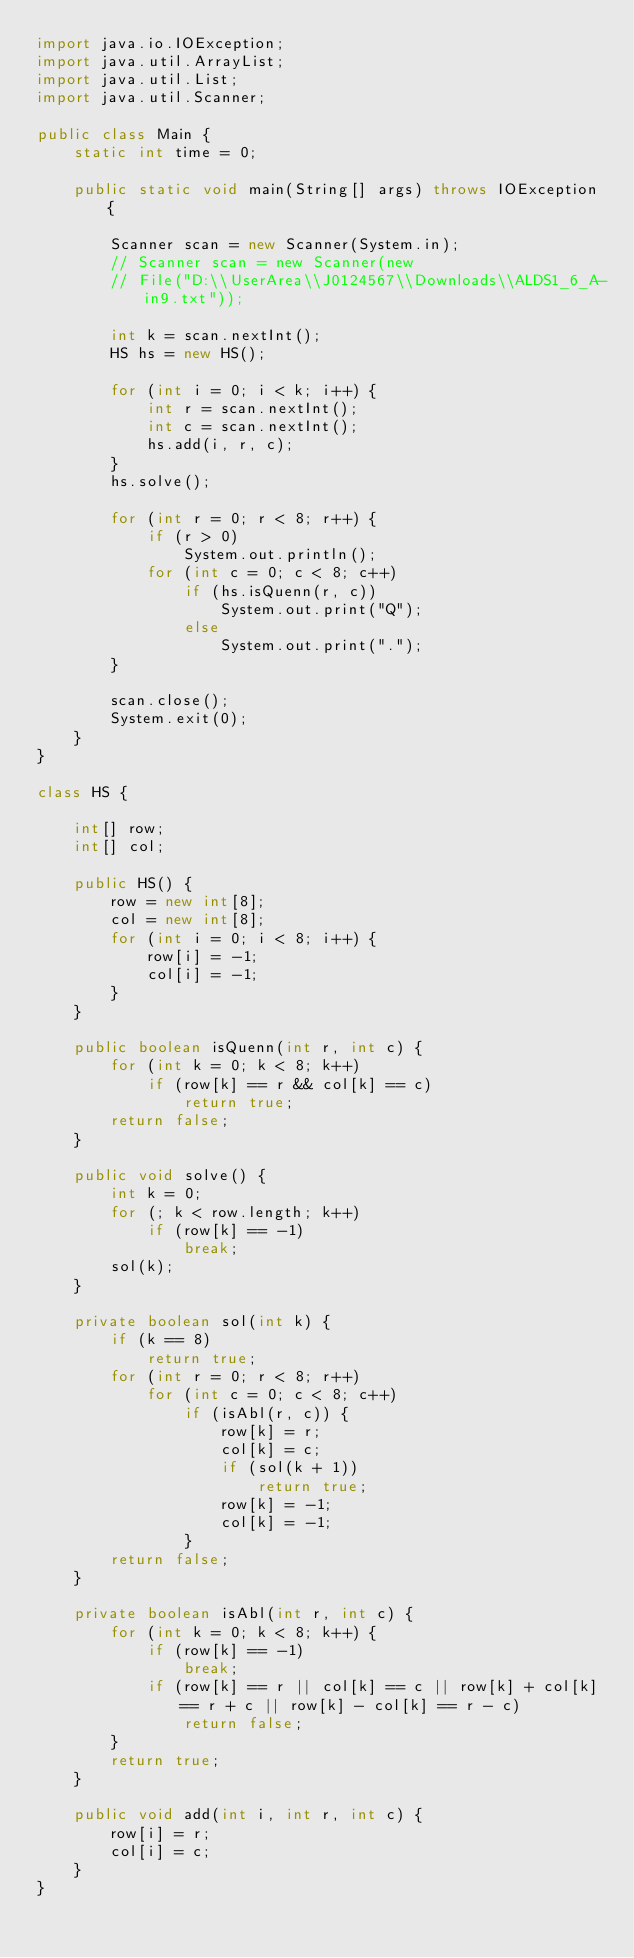Convert code to text. <code><loc_0><loc_0><loc_500><loc_500><_Java_>import java.io.IOException;
import java.util.ArrayList;
import java.util.List;
import java.util.Scanner;

public class Main {
	static int time = 0;

	public static void main(String[] args) throws IOException {

		Scanner scan = new Scanner(System.in);
		// Scanner scan = new Scanner(new
		// File("D:\\UserArea\\J0124567\\Downloads\\ALDS1_6_A-in9.txt"));

		int k = scan.nextInt();
		HS hs = new HS();

		for (int i = 0; i < k; i++) {
			int r = scan.nextInt();
			int c = scan.nextInt();
			hs.add(i, r, c);
		}
		hs.solve();

		for (int r = 0; r < 8; r++) {
			if (r > 0)
				System.out.println();
			for (int c = 0; c < 8; c++)
				if (hs.isQuenn(r, c))
					System.out.print("Q");
				else
					System.out.print(".");
		}

		scan.close();
		System.exit(0);
	}
}

class HS {

	int[] row;
	int[] col;

	public HS() {
		row = new int[8];
		col = new int[8];
		for (int i = 0; i < 8; i++) {
			row[i] = -1;
			col[i] = -1;
		}
	}

	public boolean isQuenn(int r, int c) {
		for (int k = 0; k < 8; k++)
			if (row[k] == r && col[k] == c)
				return true;
		return false;
	}

	public void solve() {
		int k = 0;
		for (; k < row.length; k++)
			if (row[k] == -1)
				break;
		sol(k);
	}

	private boolean sol(int k) {
		if (k == 8)
			return true;
		for (int r = 0; r < 8; r++)
			for (int c = 0; c < 8; c++)
				if (isAbl(r, c)) {
					row[k] = r;
					col[k] = c;
					if (sol(k + 1))
						return true;
					row[k] = -1;
					col[k] = -1;
				}
		return false;
	}

	private boolean isAbl(int r, int c) {
		for (int k = 0; k < 8; k++) {
			if (row[k] == -1)
				break;
			if (row[k] == r || col[k] == c || row[k] + col[k] == r + c || row[k] - col[k] == r - c)
				return false;
		}
		return true;
	}

	public void add(int i, int r, int c) {
		row[i] = r;
		col[i] = c;
	}
}</code> 